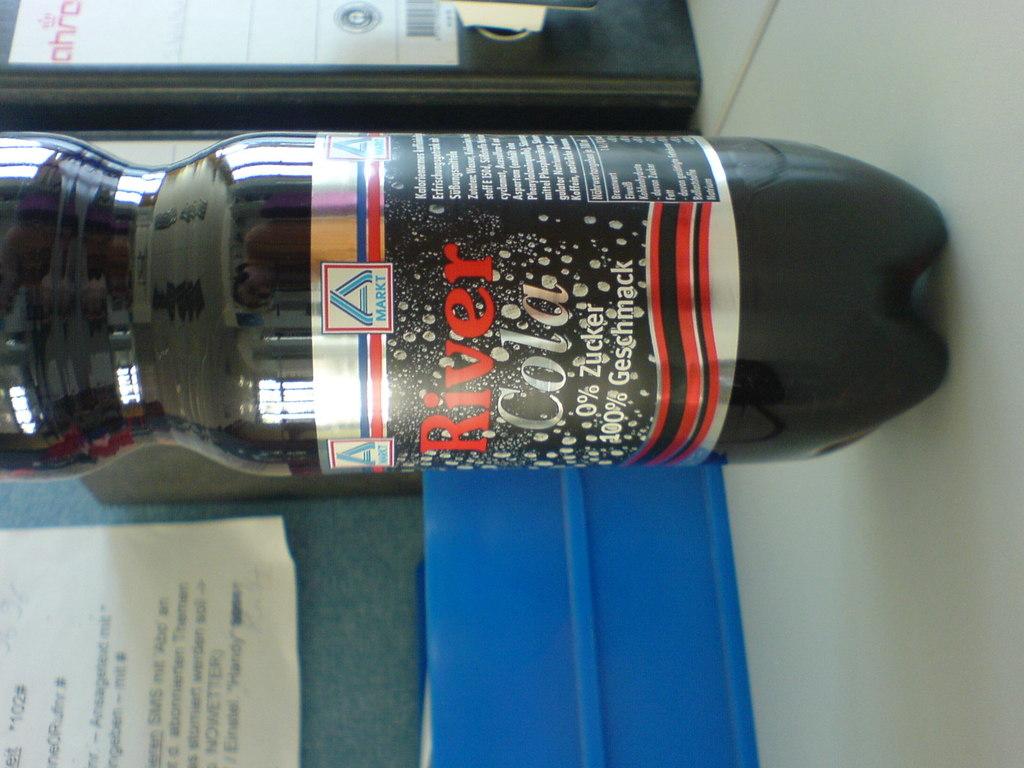What name of cola is this?
Offer a terse response. River cola. How much zucker is in this drink?
Provide a short and direct response. 0%. 